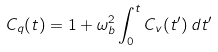Convert formula to latex. <formula><loc_0><loc_0><loc_500><loc_500>C _ { q } ( t ) = 1 + \omega _ { b } ^ { 2 } \int _ { 0 } ^ { t } C _ { v } ( t ^ { \prime } ) \, d t ^ { \prime }</formula> 